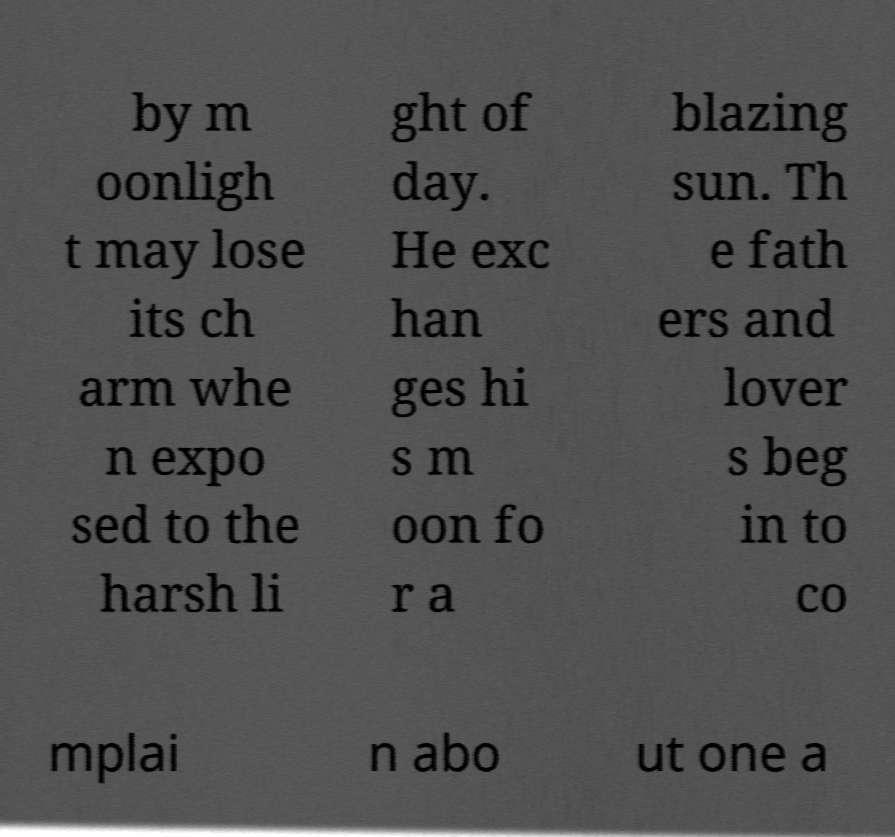What messages or text are displayed in this image? I need them in a readable, typed format. by m oonligh t may lose its ch arm whe n expo sed to the harsh li ght of day. He exc han ges hi s m oon fo r a blazing sun. Th e fath ers and lover s beg in to co mplai n abo ut one a 